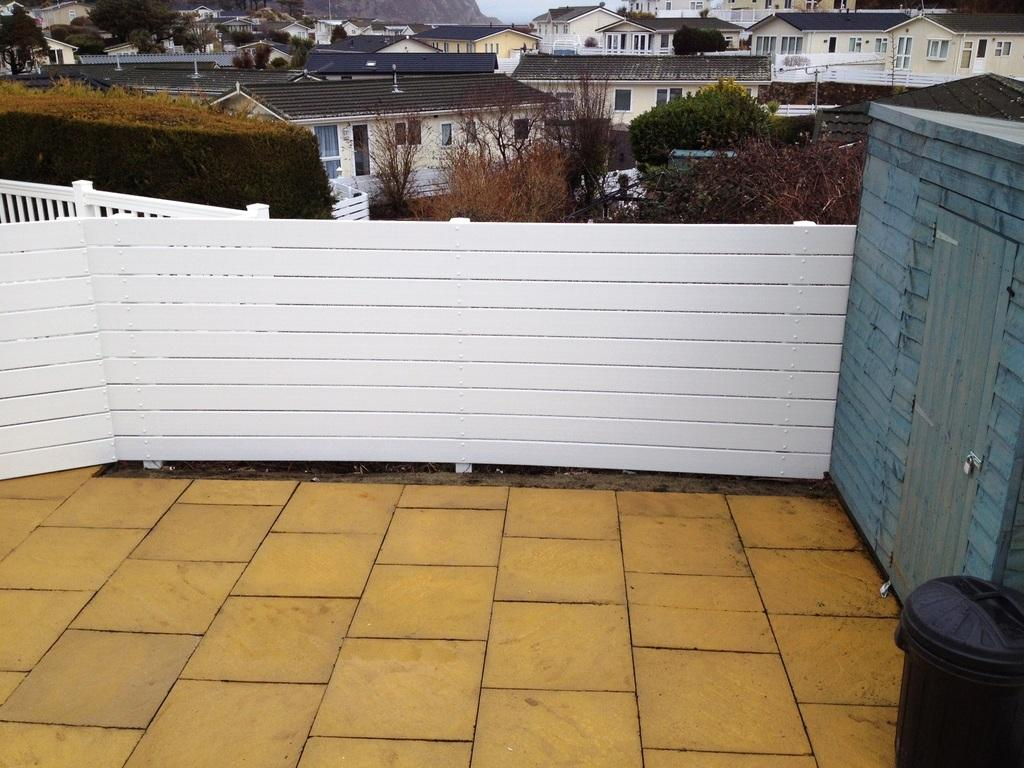What is located on the floor in the image? There is a bin on the floor in the image. What is the condition of the shed in the image? The shed has a locked door in the image. What type of enclosure can be seen in the image? There are fences in the image. What type of structures are visible in the image? There are buildings with windows in the image. What type of vegetation is present in the image? There are trees in the image. What is visible in the background of the image? The sky is visible in the background of the image. What type of behavior is exhibited by the police in the image? There are no police present in the image. How does the zipper on the shed door function in the image? The shed door is locked, so there is no zipper present in the image. 